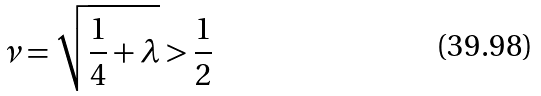Convert formula to latex. <formula><loc_0><loc_0><loc_500><loc_500>\nu = \sqrt { \frac { 1 } { 4 } + \lambda } > \frac { 1 } { 2 }</formula> 